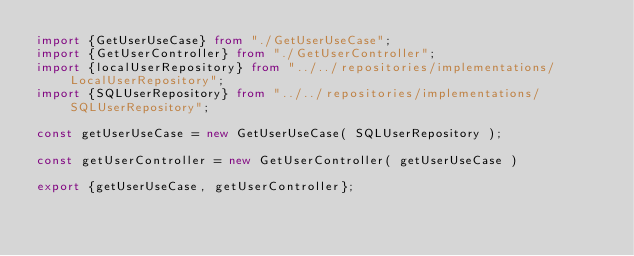<code> <loc_0><loc_0><loc_500><loc_500><_TypeScript_>import {GetUserUseCase} from "./GetUserUseCase";
import {GetUserController} from "./GetUserController";
import {localUserRepository} from "../../repositories/implementations/LocalUserRepository";
import {SQLUserRepository} from "../../repositories/implementations/SQLUserRepository";

const getUserUseCase = new GetUserUseCase( SQLUserRepository );

const getUserController = new GetUserController( getUserUseCase )

export {getUserUseCase, getUserController};</code> 